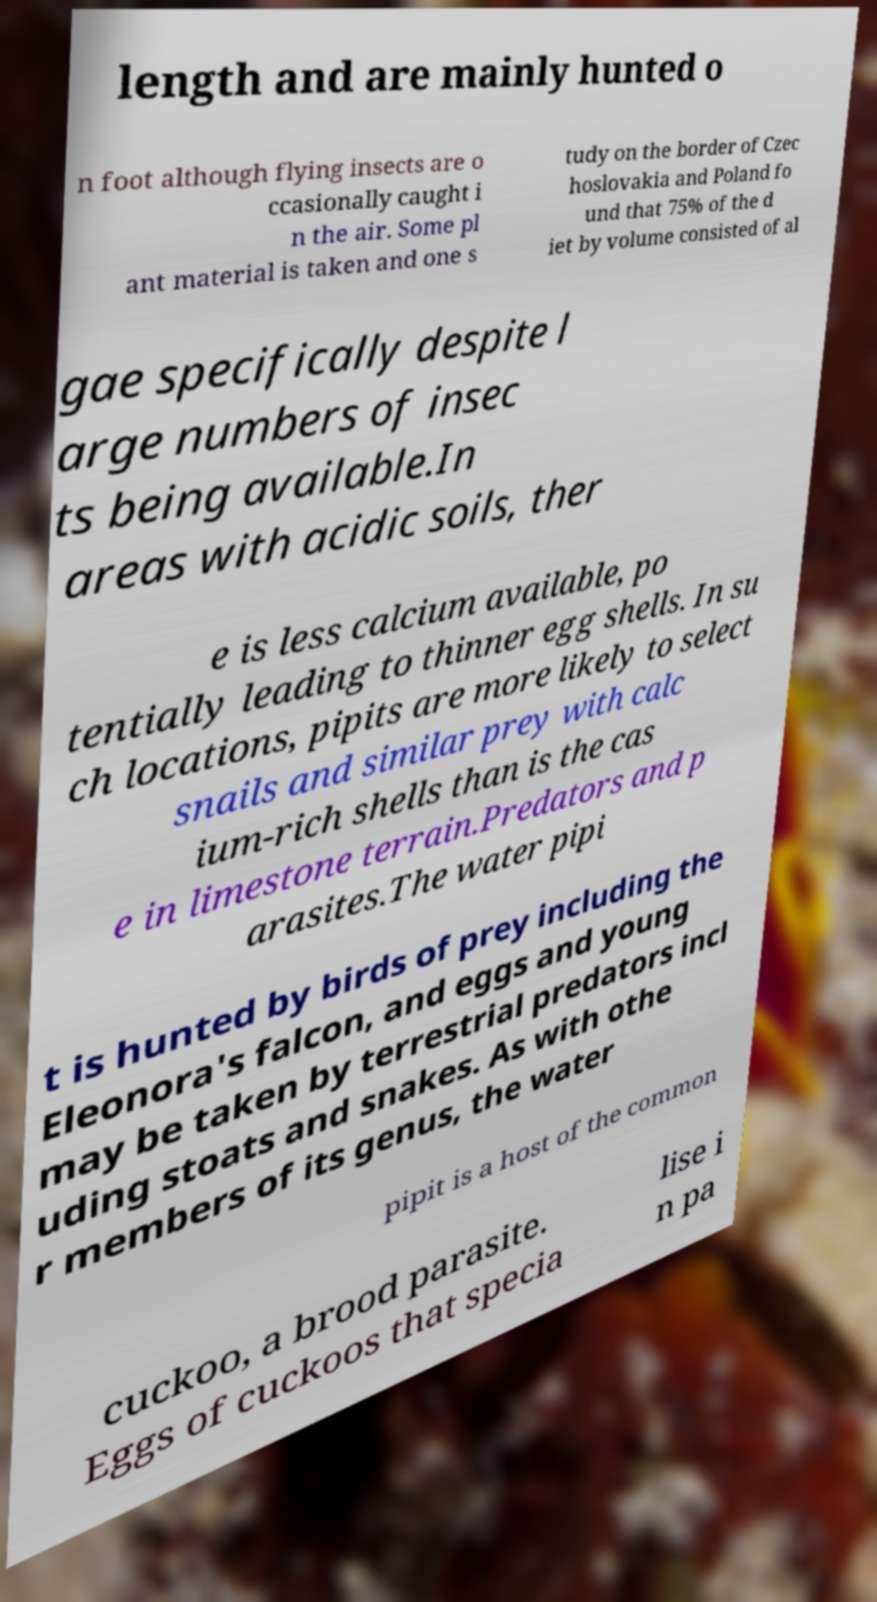For documentation purposes, I need the text within this image transcribed. Could you provide that? length and are mainly hunted o n foot although flying insects are o ccasionally caught i n the air. Some pl ant material is taken and one s tudy on the border of Czec hoslovakia and Poland fo und that 75% of the d iet by volume consisted of al gae specifically despite l arge numbers of insec ts being available.In areas with acidic soils, ther e is less calcium available, po tentially leading to thinner egg shells. In su ch locations, pipits are more likely to select snails and similar prey with calc ium-rich shells than is the cas e in limestone terrain.Predators and p arasites.The water pipi t is hunted by birds of prey including the Eleonora's falcon, and eggs and young may be taken by terrestrial predators incl uding stoats and snakes. As with othe r members of its genus, the water pipit is a host of the common cuckoo, a brood parasite. Eggs of cuckoos that specia lise i n pa 